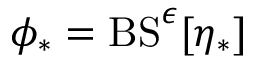Convert formula to latex. <formula><loc_0><loc_0><loc_500><loc_500>\phi _ { * } = B S ^ { \epsilon } [ \eta _ { * } ]</formula> 